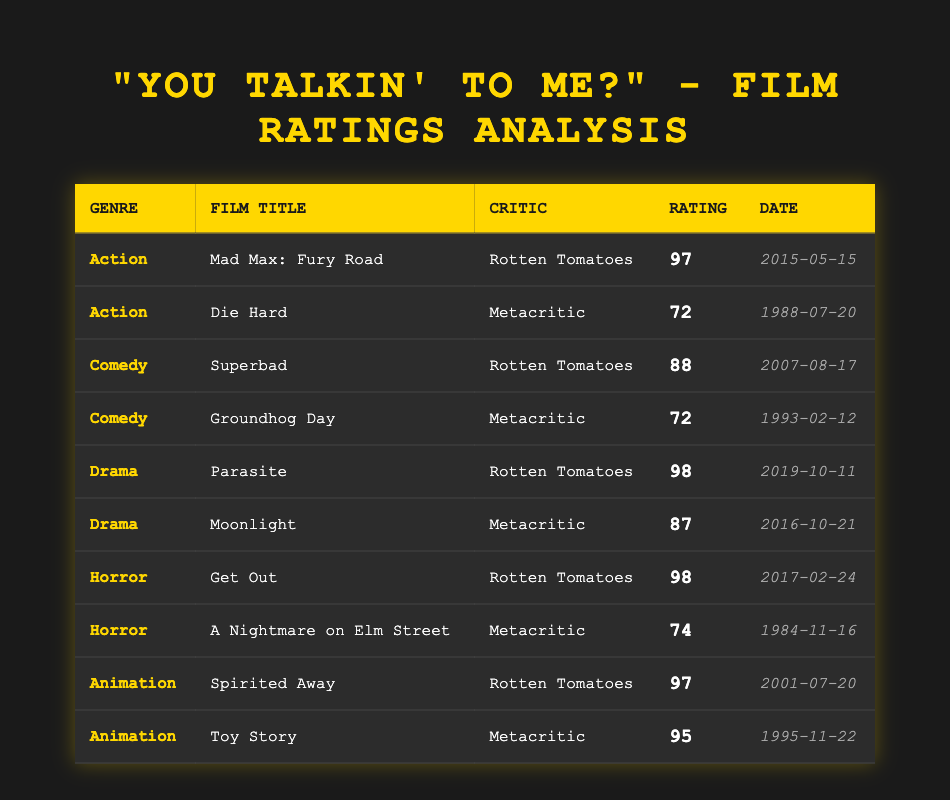What is the highest rating for an Action film based on critics? The table shows that "Mad Max: Fury Road" has the highest rating of 97 from Rotten Tomatoes among Action films.
Answer: 97 Which film received the lowest rating from all critics? By examining the ratings, "Die Hard" received a rating of 72 from Metacritic, which is the lowest among all films in the table.
Answer: 72 Are there more Horror films or Animated films listed in the table? There are 2 Horror films ("Get Out" and "A Nightmare on Elm Street") and 2 Animated films ("Spirited Away" and "Toy Story") in the table. Since they are equal, there is no category with more films.
Answer: No What is the average rating of Comedy films? The ratings for the Comedy films are 88 for "Superbad" and 72 for "Groundhog Day." To find the average, sum these ratings (88 + 72 = 160) and divide by the number of films (2). Therefore, the average is 160/2 = 80.
Answer: 80 Which genre has the film with the highest rating overall? The film "Parasite" from the Drama genre has the highest rating of 98 from Rotten Tomatoes, which is higher than any other films in the table.
Answer: Drama Is there a film in the table that received a rating of 87? Yes, the film "Moonlight" received a rating of 87 from Metacritic.
Answer: Yes Which critic gave the highest rating to any film in the Horror genre? "Get Out," rated 98 by Rotten Tomatoes, is the highest rating in the Horror genre. Therefore, Rotten Tomatoes gave the highest rating for a Horror film.
Answer: Rotten Tomatoes What rating did the Animation film "Toy Story" receive, and how does it compare with "Spirited Away"? "Toy Story" received a rating of 95 from Metacritic, while "Spirited Away" received a rating of 97 from Rotten Tomatoes. "Spirited Away" has a higher rating by 2 points compared to "Toy Story."
Answer: 95, Spirited Away is higher by 2 points 